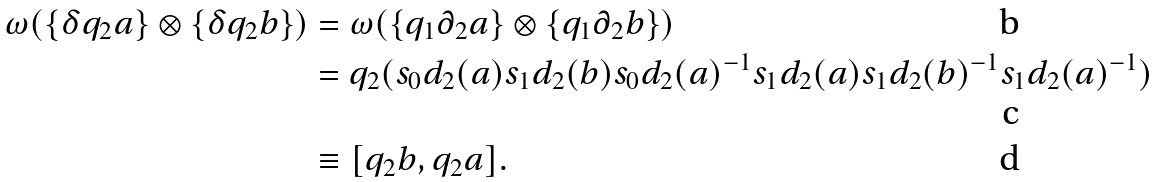Convert formula to latex. <formula><loc_0><loc_0><loc_500><loc_500>\omega ( \{ \delta q _ { 2 } a \} \otimes \{ \delta q _ { 2 } b \} ) & = \omega ( \{ q _ { 1 } \partial _ { 2 } a \} \otimes \{ q _ { 1 } \partial _ { 2 } b \} ) \\ & = q _ { 2 } ( s _ { 0 } d _ { 2 } ( a ) s _ { 1 } d _ { 2 } ( b ) s _ { 0 } d _ { 2 } ( a ) ^ { - 1 } s _ { 1 } d _ { 2 } ( a ) s _ { 1 } d _ { 2 } ( b ) ^ { - 1 } s _ { 1 } d _ { 2 } ( a ) ^ { - 1 } ) \\ & \equiv [ q _ { 2 } b , q _ { 2 } a ] .</formula> 